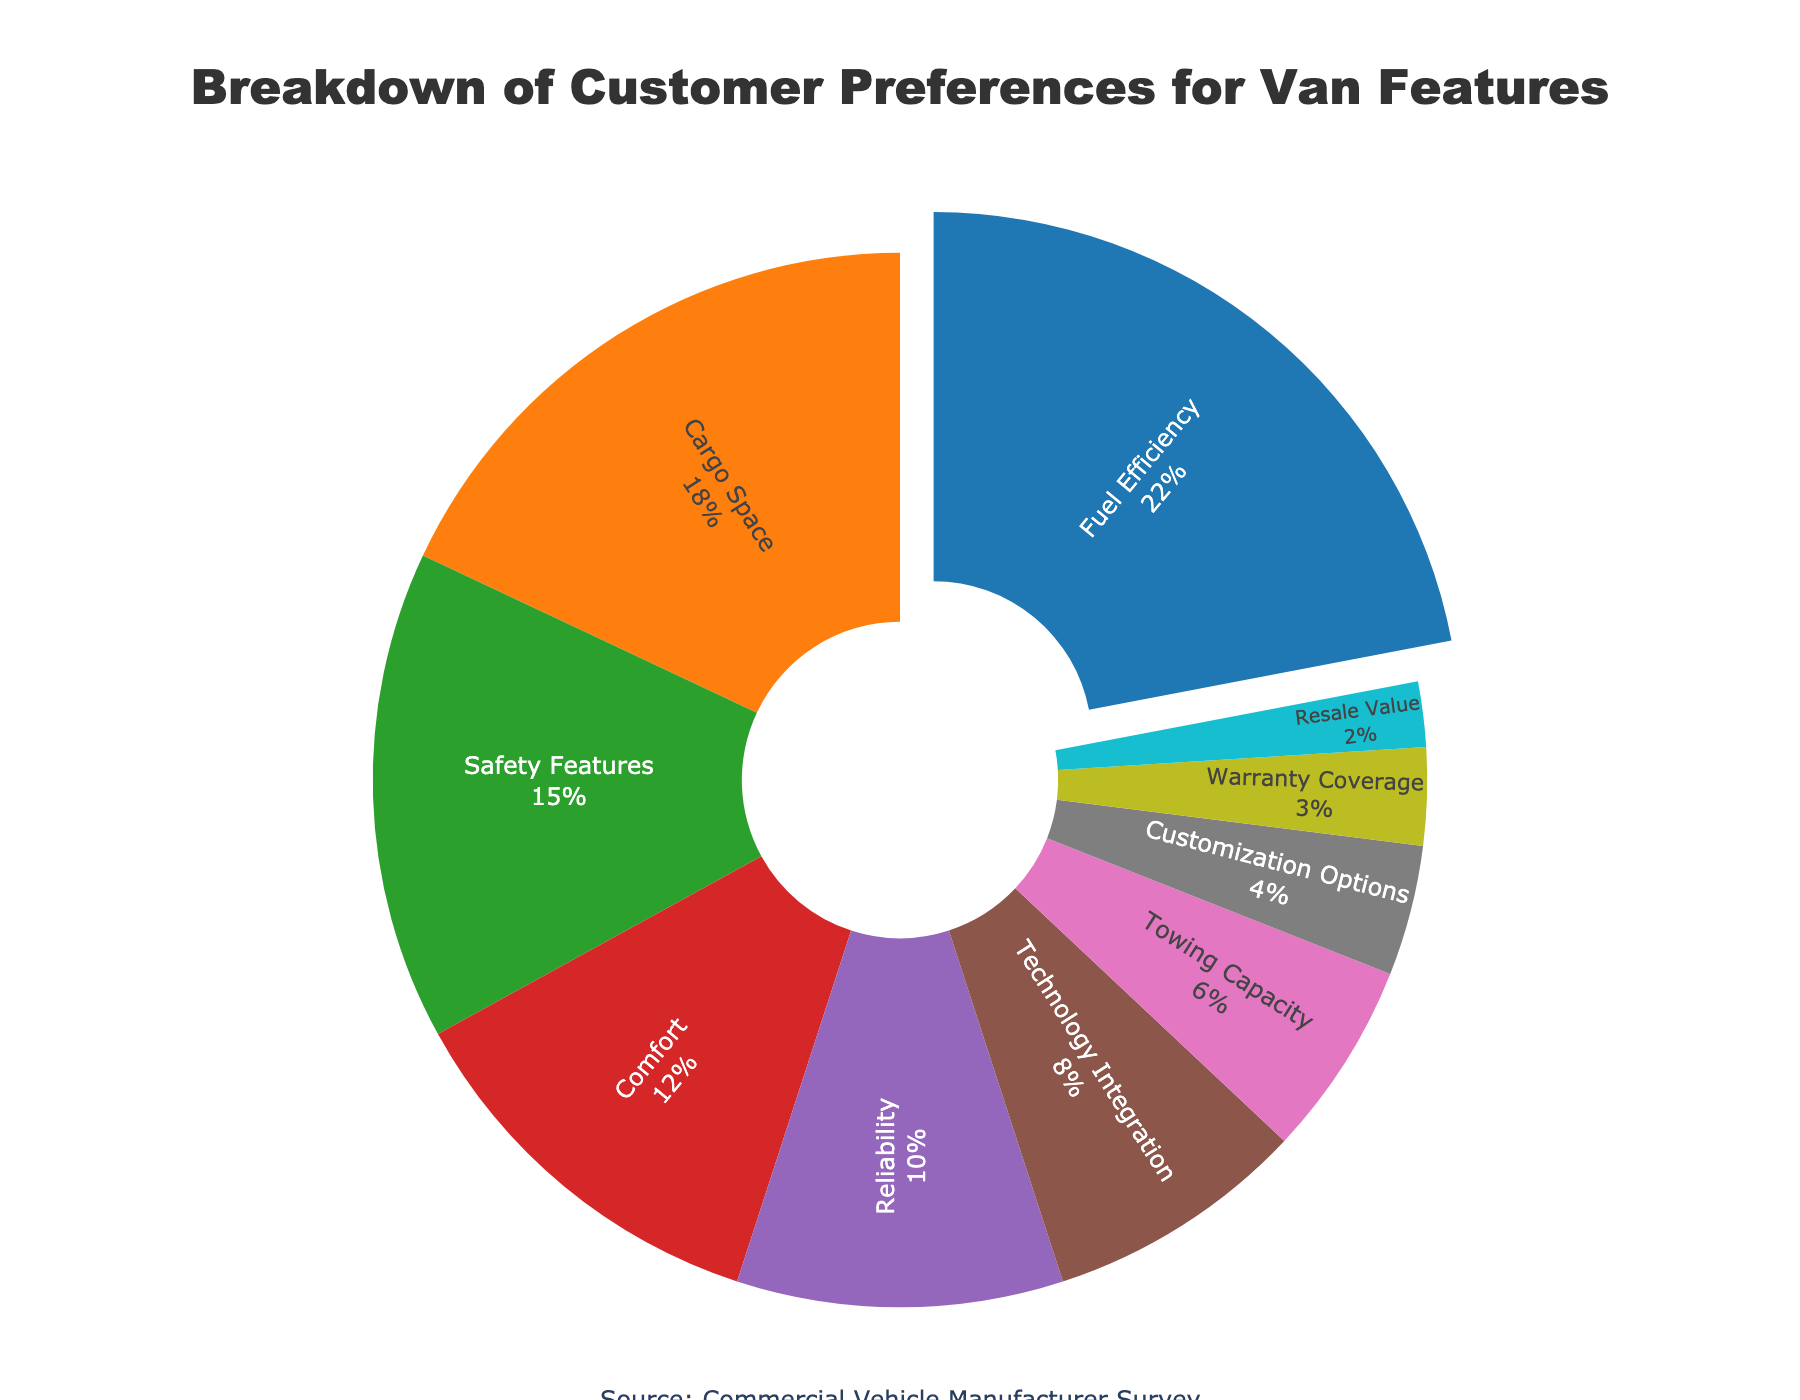What's the most preferred feature of the van according to the pie chart? The pie chart shows that 'Fuel Efficiency' has the largest segment, which indicates the highest percentage at 22%.
Answer: Fuel Efficiency Which three features have the highest percentages? According to the pie chart, the three largest sections are 'Fuel Efficiency' (22%), 'Cargo Space' (18%), and 'Safety Features' (15%).
Answer: Fuel Efficiency, Cargo Space, Safety Features How does the percentage for 'Comfort' compare to 'Reliability'? The chart indicates 'Comfort' at 12% and 'Reliability' at 10%. Hence, 'Comfort' has a higher percentage than 'Reliability'.
Answer: Comfort has a higher percentage What is the combined percentage of 'Technology Integration' and 'Customization Options'? The chart shows 'Technology Integration' at 8% and 'Customization Options' at 4%. Adding these together gives 8% + 4% = 12%.
Answer: 12% What is the smallest segment in the pie chart, and what is its percentage? The smallest segment corresponds to 'Resale Value', which accounts for 2% of the total preferences.
Answer: Resale Value, 2% Are 'Safety Features' and 'Comfort' together preferred more than 'Cargo Space'? The chart gives 'Safety Features' a 15% share and 'Comfort' a 12% share. Their combined percentage is 15% + 12% = 27%, which is greater than 'Cargo Space's 18%.
Answer: Yes How much larger is the 'Fuel Efficiency' segment than the 'Warranty Coverage' segment? 'Fuel Efficiency' has a share of 22%, while 'Warranty Coverage' is at 3%. The difference is 22% - 3% = 19%.
Answer: 19% Which segment is represented by a purple color in the chart? According to the color scheme used, 'Reliability' appears as the purple segment in the pie chart.
Answer: Reliability Is the 'Towing Capacity' segment larger than 'Customization Options'? 'Towing Capacity' has a share of 6%, which is larger compared to the 4% share of 'Customization Options'.
Answer: Yes What is the average percentage for 'Cargo Space', 'Safety Features', and 'Comfort'? The percentages for 'Cargo Space' (18%), 'Safety Features' (15%), and 'Comfort' (12%) need to be averaged: (18% + 15% + 12%) / 3 = 45% / 3 = 15%.
Answer: 15% 